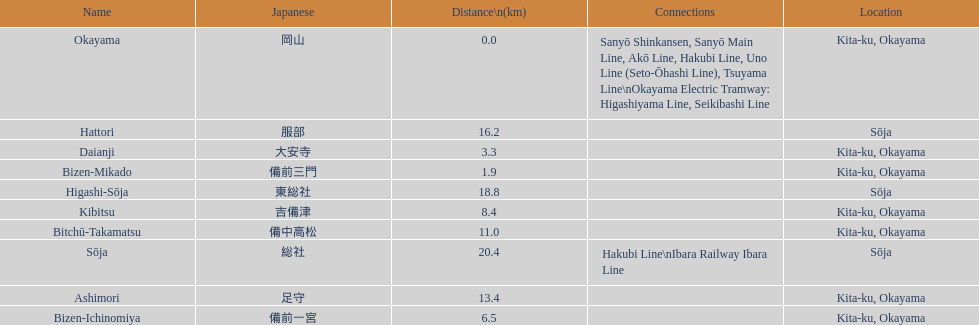Name only the stations that have connections to other lines. Okayama, Sōja. 